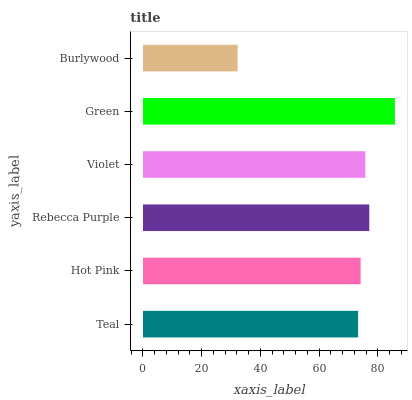Is Burlywood the minimum?
Answer yes or no. Yes. Is Green the maximum?
Answer yes or no. Yes. Is Hot Pink the minimum?
Answer yes or no. No. Is Hot Pink the maximum?
Answer yes or no. No. Is Hot Pink greater than Teal?
Answer yes or no. Yes. Is Teal less than Hot Pink?
Answer yes or no. Yes. Is Teal greater than Hot Pink?
Answer yes or no. No. Is Hot Pink less than Teal?
Answer yes or no. No. Is Violet the high median?
Answer yes or no. Yes. Is Hot Pink the low median?
Answer yes or no. Yes. Is Burlywood the high median?
Answer yes or no. No. Is Teal the low median?
Answer yes or no. No. 